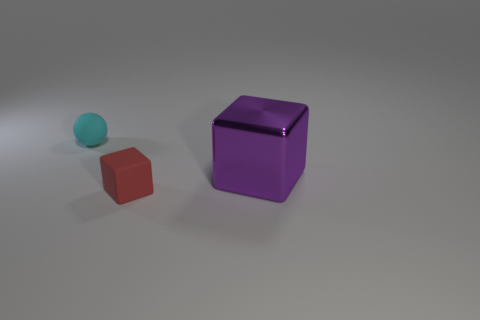How many matte things are tiny blue blocks or purple blocks? 0 